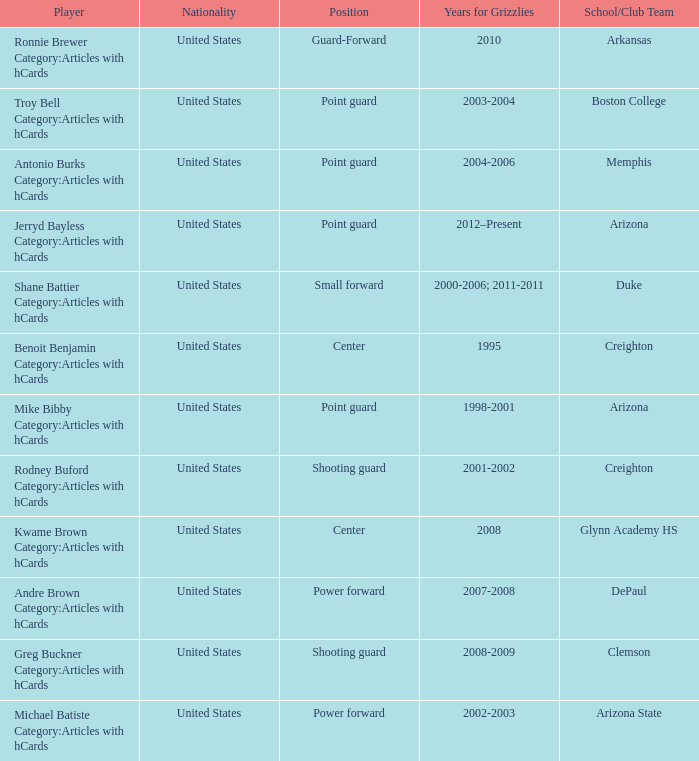Which Player has position of power forward and School/Club Team of Depaul? Andre Brown Category:Articles with hCards. 